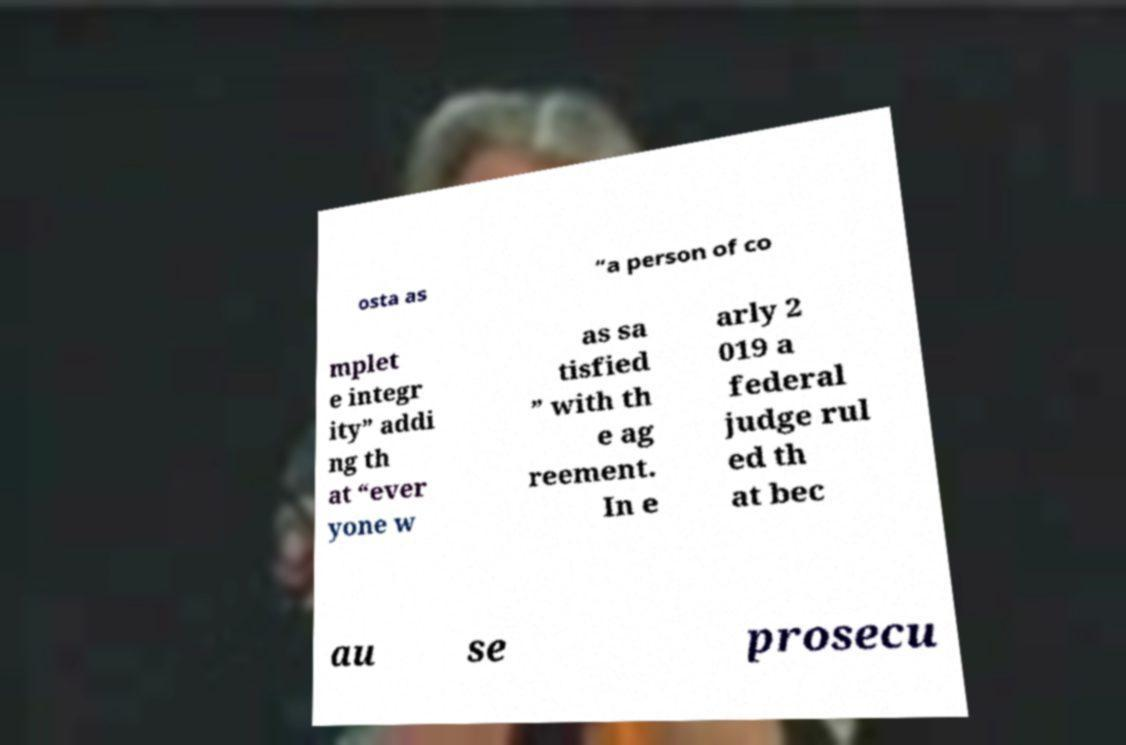I need the written content from this picture converted into text. Can you do that? osta as “a person of co mplet e integr ity” addi ng th at “ever yone w as sa tisfied ” with th e ag reement. In e arly 2 019 a federal judge rul ed th at bec au se prosecu 